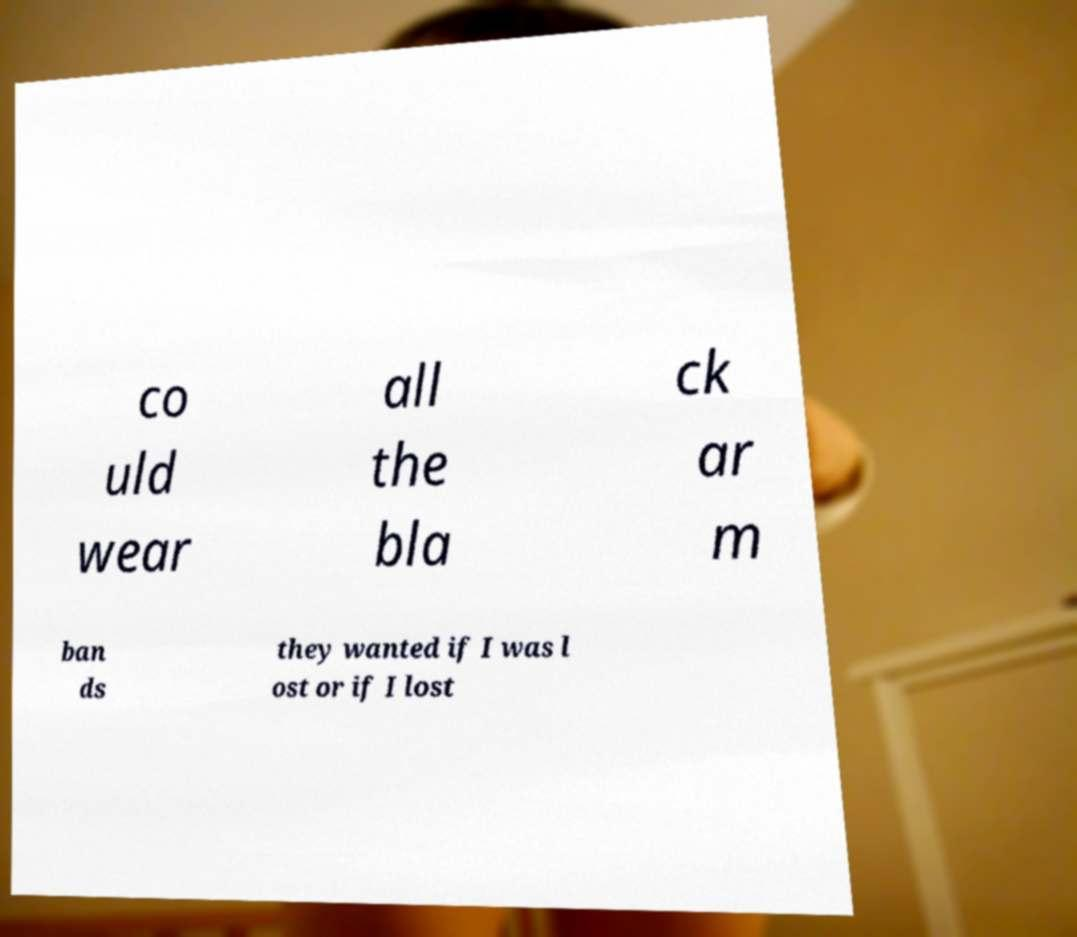What messages or text are displayed in this image? I need them in a readable, typed format. co uld wear all the bla ck ar m ban ds they wanted if I was l ost or if I lost 